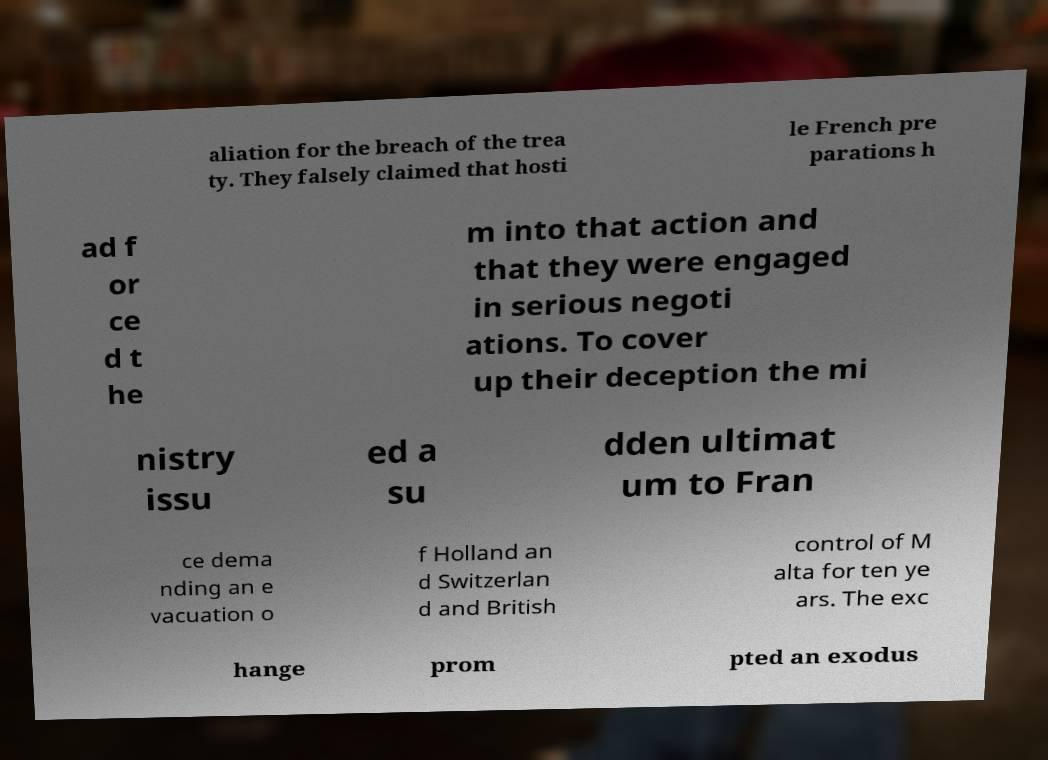Could you extract and type out the text from this image? aliation for the breach of the trea ty. They falsely claimed that hosti le French pre parations h ad f or ce d t he m into that action and that they were engaged in serious negoti ations. To cover up their deception the mi nistry issu ed a su dden ultimat um to Fran ce dema nding an e vacuation o f Holland an d Switzerlan d and British control of M alta for ten ye ars. The exc hange prom pted an exodus 